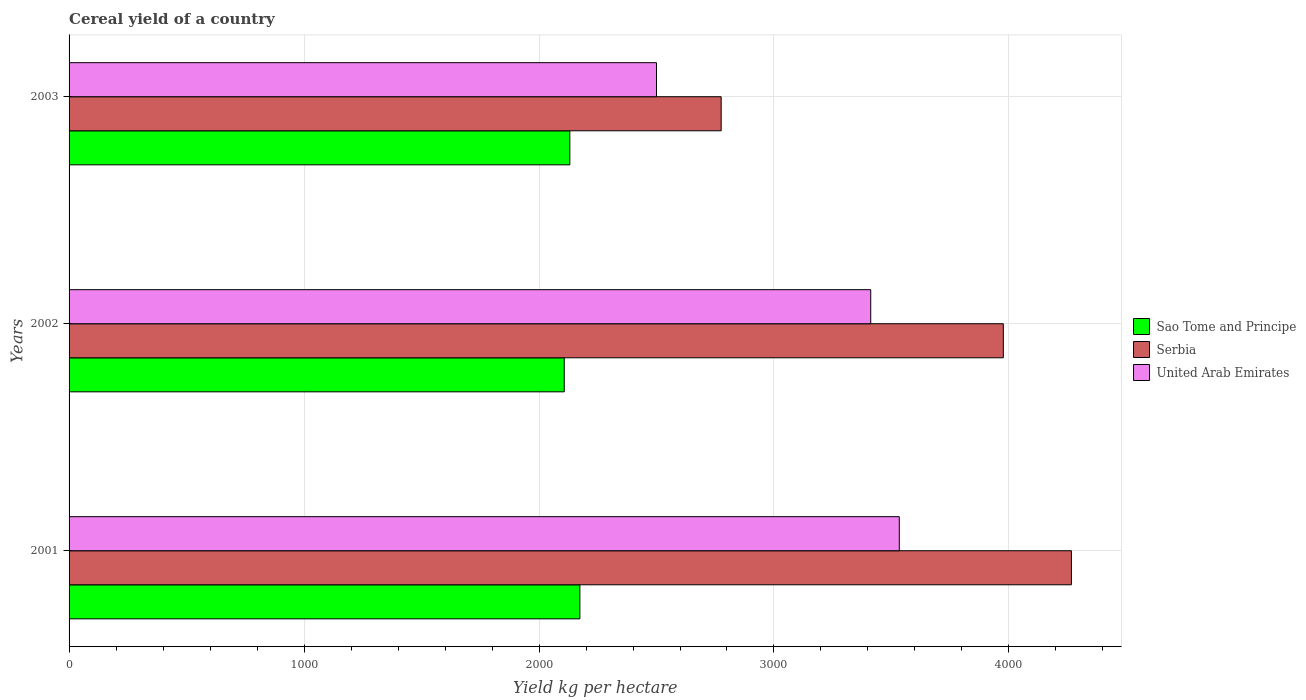How many groups of bars are there?
Provide a succinct answer. 3. Are the number of bars per tick equal to the number of legend labels?
Keep it short and to the point. Yes. Are the number of bars on each tick of the Y-axis equal?
Give a very brief answer. Yes. What is the label of the 1st group of bars from the top?
Keep it short and to the point. 2003. In how many cases, is the number of bars for a given year not equal to the number of legend labels?
Provide a succinct answer. 0. What is the total cereal yield in United Arab Emirates in 2001?
Ensure brevity in your answer.  3533.33. Across all years, what is the maximum total cereal yield in United Arab Emirates?
Offer a very short reply. 3533.33. Across all years, what is the minimum total cereal yield in Sao Tome and Principe?
Keep it short and to the point. 2107.44. In which year was the total cereal yield in United Arab Emirates maximum?
Make the answer very short. 2001. In which year was the total cereal yield in Serbia minimum?
Your response must be concise. 2003. What is the total total cereal yield in Serbia in the graph?
Your answer should be very brief. 1.10e+04. What is the difference between the total cereal yield in United Arab Emirates in 2001 and that in 2003?
Offer a very short reply. 1033.33. What is the difference between the total cereal yield in Sao Tome and Principe in 2001 and the total cereal yield in United Arab Emirates in 2002?
Keep it short and to the point. -1237.85. What is the average total cereal yield in United Arab Emirates per year?
Ensure brevity in your answer.  3148.37. In the year 2003, what is the difference between the total cereal yield in United Arab Emirates and total cereal yield in Serbia?
Your answer should be very brief. -275.25. What is the ratio of the total cereal yield in Sao Tome and Principe in 2001 to that in 2002?
Provide a succinct answer. 1.03. Is the total cereal yield in Serbia in 2002 less than that in 2003?
Ensure brevity in your answer.  No. Is the difference between the total cereal yield in United Arab Emirates in 2002 and 2003 greater than the difference between the total cereal yield in Serbia in 2002 and 2003?
Offer a terse response. No. What is the difference between the highest and the second highest total cereal yield in Serbia?
Make the answer very short. 289.71. What is the difference between the highest and the lowest total cereal yield in Serbia?
Your response must be concise. 1490.56. What does the 2nd bar from the top in 2003 represents?
Your answer should be very brief. Serbia. What does the 3rd bar from the bottom in 2001 represents?
Offer a very short reply. United Arab Emirates. Is it the case that in every year, the sum of the total cereal yield in Serbia and total cereal yield in Sao Tome and Principe is greater than the total cereal yield in United Arab Emirates?
Keep it short and to the point. Yes. How many bars are there?
Provide a short and direct response. 9. Are the values on the major ticks of X-axis written in scientific E-notation?
Your answer should be very brief. No. Does the graph contain grids?
Give a very brief answer. Yes. Where does the legend appear in the graph?
Keep it short and to the point. Center right. How many legend labels are there?
Provide a short and direct response. 3. How are the legend labels stacked?
Ensure brevity in your answer.  Vertical. What is the title of the graph?
Provide a succinct answer. Cereal yield of a country. Does "Yemen, Rep." appear as one of the legend labels in the graph?
Give a very brief answer. No. What is the label or title of the X-axis?
Ensure brevity in your answer.  Yield kg per hectare. What is the label or title of the Y-axis?
Provide a short and direct response. Years. What is the Yield kg per hectare in Sao Tome and Principe in 2001?
Ensure brevity in your answer.  2173.91. What is the Yield kg per hectare of Serbia in 2001?
Provide a succinct answer. 4265.81. What is the Yield kg per hectare of United Arab Emirates in 2001?
Ensure brevity in your answer.  3533.33. What is the Yield kg per hectare of Sao Tome and Principe in 2002?
Keep it short and to the point. 2107.44. What is the Yield kg per hectare in Serbia in 2002?
Offer a very short reply. 3976.1. What is the Yield kg per hectare of United Arab Emirates in 2002?
Your response must be concise. 3411.76. What is the Yield kg per hectare in Sao Tome and Principe in 2003?
Offer a very short reply. 2131.15. What is the Yield kg per hectare of Serbia in 2003?
Provide a succinct answer. 2775.25. What is the Yield kg per hectare of United Arab Emirates in 2003?
Your response must be concise. 2500. Across all years, what is the maximum Yield kg per hectare in Sao Tome and Principe?
Your response must be concise. 2173.91. Across all years, what is the maximum Yield kg per hectare in Serbia?
Ensure brevity in your answer.  4265.81. Across all years, what is the maximum Yield kg per hectare in United Arab Emirates?
Ensure brevity in your answer.  3533.33. Across all years, what is the minimum Yield kg per hectare of Sao Tome and Principe?
Your answer should be compact. 2107.44. Across all years, what is the minimum Yield kg per hectare of Serbia?
Offer a very short reply. 2775.25. Across all years, what is the minimum Yield kg per hectare of United Arab Emirates?
Offer a terse response. 2500. What is the total Yield kg per hectare of Sao Tome and Principe in the graph?
Your answer should be compact. 6412.5. What is the total Yield kg per hectare in Serbia in the graph?
Keep it short and to the point. 1.10e+04. What is the total Yield kg per hectare in United Arab Emirates in the graph?
Keep it short and to the point. 9445.1. What is the difference between the Yield kg per hectare in Sao Tome and Principe in 2001 and that in 2002?
Provide a short and direct response. 66.47. What is the difference between the Yield kg per hectare of Serbia in 2001 and that in 2002?
Provide a short and direct response. 289.71. What is the difference between the Yield kg per hectare of United Arab Emirates in 2001 and that in 2002?
Your response must be concise. 121.57. What is the difference between the Yield kg per hectare in Sao Tome and Principe in 2001 and that in 2003?
Your answer should be compact. 42.77. What is the difference between the Yield kg per hectare of Serbia in 2001 and that in 2003?
Your answer should be compact. 1490.56. What is the difference between the Yield kg per hectare in United Arab Emirates in 2001 and that in 2003?
Your answer should be compact. 1033.33. What is the difference between the Yield kg per hectare of Sao Tome and Principe in 2002 and that in 2003?
Provide a short and direct response. -23.71. What is the difference between the Yield kg per hectare of Serbia in 2002 and that in 2003?
Provide a short and direct response. 1200.85. What is the difference between the Yield kg per hectare of United Arab Emirates in 2002 and that in 2003?
Your answer should be compact. 911.76. What is the difference between the Yield kg per hectare in Sao Tome and Principe in 2001 and the Yield kg per hectare in Serbia in 2002?
Your answer should be compact. -1802.19. What is the difference between the Yield kg per hectare of Sao Tome and Principe in 2001 and the Yield kg per hectare of United Arab Emirates in 2002?
Offer a terse response. -1237.85. What is the difference between the Yield kg per hectare in Serbia in 2001 and the Yield kg per hectare in United Arab Emirates in 2002?
Your answer should be compact. 854.04. What is the difference between the Yield kg per hectare of Sao Tome and Principe in 2001 and the Yield kg per hectare of Serbia in 2003?
Make the answer very short. -601.34. What is the difference between the Yield kg per hectare in Sao Tome and Principe in 2001 and the Yield kg per hectare in United Arab Emirates in 2003?
Make the answer very short. -326.09. What is the difference between the Yield kg per hectare in Serbia in 2001 and the Yield kg per hectare in United Arab Emirates in 2003?
Your answer should be very brief. 1765.81. What is the difference between the Yield kg per hectare in Sao Tome and Principe in 2002 and the Yield kg per hectare in Serbia in 2003?
Your answer should be compact. -667.81. What is the difference between the Yield kg per hectare in Sao Tome and Principe in 2002 and the Yield kg per hectare in United Arab Emirates in 2003?
Offer a very short reply. -392.56. What is the difference between the Yield kg per hectare in Serbia in 2002 and the Yield kg per hectare in United Arab Emirates in 2003?
Your answer should be very brief. 1476.1. What is the average Yield kg per hectare in Sao Tome and Principe per year?
Your response must be concise. 2137.5. What is the average Yield kg per hectare of Serbia per year?
Provide a short and direct response. 3672.39. What is the average Yield kg per hectare of United Arab Emirates per year?
Ensure brevity in your answer.  3148.37. In the year 2001, what is the difference between the Yield kg per hectare of Sao Tome and Principe and Yield kg per hectare of Serbia?
Provide a short and direct response. -2091.89. In the year 2001, what is the difference between the Yield kg per hectare of Sao Tome and Principe and Yield kg per hectare of United Arab Emirates?
Your answer should be very brief. -1359.42. In the year 2001, what is the difference between the Yield kg per hectare in Serbia and Yield kg per hectare in United Arab Emirates?
Provide a short and direct response. 732.48. In the year 2002, what is the difference between the Yield kg per hectare of Sao Tome and Principe and Yield kg per hectare of Serbia?
Make the answer very short. -1868.66. In the year 2002, what is the difference between the Yield kg per hectare in Sao Tome and Principe and Yield kg per hectare in United Arab Emirates?
Your response must be concise. -1304.33. In the year 2002, what is the difference between the Yield kg per hectare of Serbia and Yield kg per hectare of United Arab Emirates?
Provide a succinct answer. 564.34. In the year 2003, what is the difference between the Yield kg per hectare in Sao Tome and Principe and Yield kg per hectare in Serbia?
Ensure brevity in your answer.  -644.1. In the year 2003, what is the difference between the Yield kg per hectare of Sao Tome and Principe and Yield kg per hectare of United Arab Emirates?
Your answer should be compact. -368.85. In the year 2003, what is the difference between the Yield kg per hectare of Serbia and Yield kg per hectare of United Arab Emirates?
Keep it short and to the point. 275.25. What is the ratio of the Yield kg per hectare in Sao Tome and Principe in 2001 to that in 2002?
Ensure brevity in your answer.  1.03. What is the ratio of the Yield kg per hectare in Serbia in 2001 to that in 2002?
Provide a succinct answer. 1.07. What is the ratio of the Yield kg per hectare in United Arab Emirates in 2001 to that in 2002?
Provide a succinct answer. 1.04. What is the ratio of the Yield kg per hectare of Sao Tome and Principe in 2001 to that in 2003?
Provide a succinct answer. 1.02. What is the ratio of the Yield kg per hectare of Serbia in 2001 to that in 2003?
Offer a very short reply. 1.54. What is the ratio of the Yield kg per hectare in United Arab Emirates in 2001 to that in 2003?
Your response must be concise. 1.41. What is the ratio of the Yield kg per hectare in Sao Tome and Principe in 2002 to that in 2003?
Provide a short and direct response. 0.99. What is the ratio of the Yield kg per hectare of Serbia in 2002 to that in 2003?
Provide a short and direct response. 1.43. What is the ratio of the Yield kg per hectare of United Arab Emirates in 2002 to that in 2003?
Keep it short and to the point. 1.36. What is the difference between the highest and the second highest Yield kg per hectare in Sao Tome and Principe?
Offer a terse response. 42.77. What is the difference between the highest and the second highest Yield kg per hectare of Serbia?
Your answer should be compact. 289.71. What is the difference between the highest and the second highest Yield kg per hectare in United Arab Emirates?
Offer a terse response. 121.57. What is the difference between the highest and the lowest Yield kg per hectare of Sao Tome and Principe?
Your answer should be very brief. 66.47. What is the difference between the highest and the lowest Yield kg per hectare of Serbia?
Provide a short and direct response. 1490.56. What is the difference between the highest and the lowest Yield kg per hectare in United Arab Emirates?
Offer a terse response. 1033.33. 